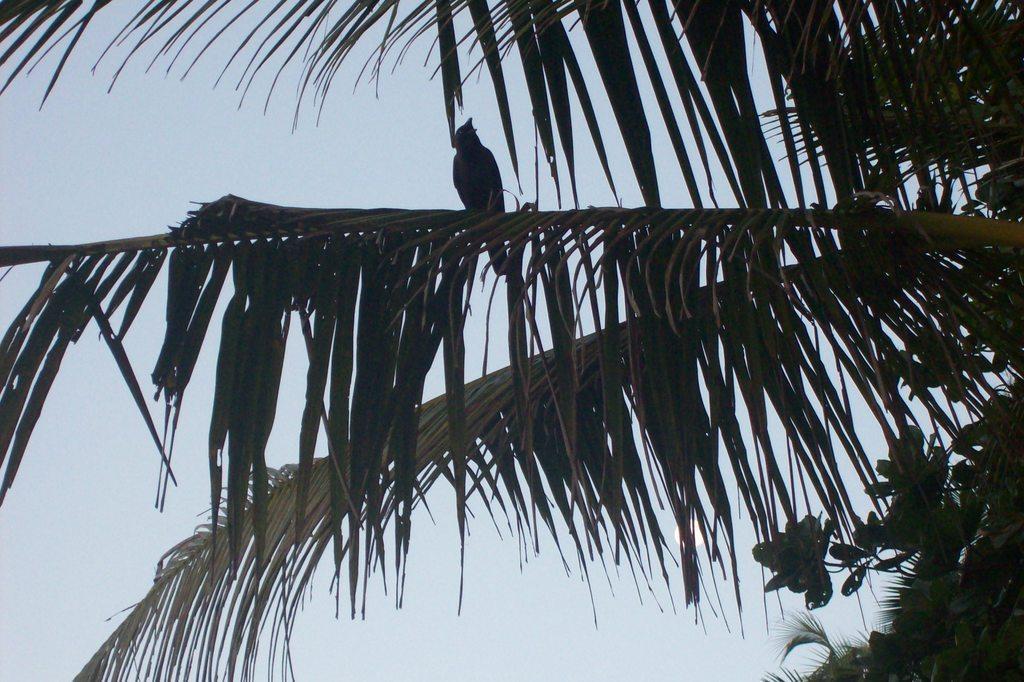Could you give a brief overview of what you see in this image? In this picture in the front there are leaves and there is a bird standing on the branch of a tree and the sky is cloudy. 